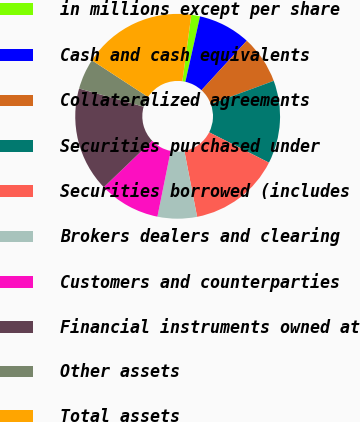<chart> <loc_0><loc_0><loc_500><loc_500><pie_chart><fcel>in millions except per share<fcel>Cash and cash equivalents<fcel>Collateralized agreements<fcel>Securities purchased under<fcel>Securities borrowed (includes<fcel>Brokers dealers and clearing<fcel>Customers and counterparties<fcel>Financial instruments owned at<fcel>Other assets<fcel>Total assets<nl><fcel>1.38%<fcel>8.28%<fcel>7.59%<fcel>13.1%<fcel>14.48%<fcel>6.21%<fcel>9.66%<fcel>16.55%<fcel>4.83%<fcel>17.93%<nl></chart> 